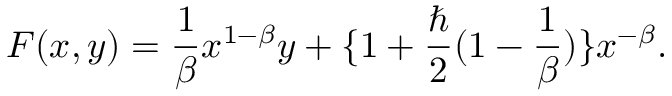<formula> <loc_0><loc_0><loc_500><loc_500>F ( x , y ) = \frac { 1 } { \beta } x ^ { 1 - \beta } y + \{ 1 + \frac { } { 2 } ( 1 - \frac { 1 } { \beta } ) \} x ^ { - \beta } .</formula> 